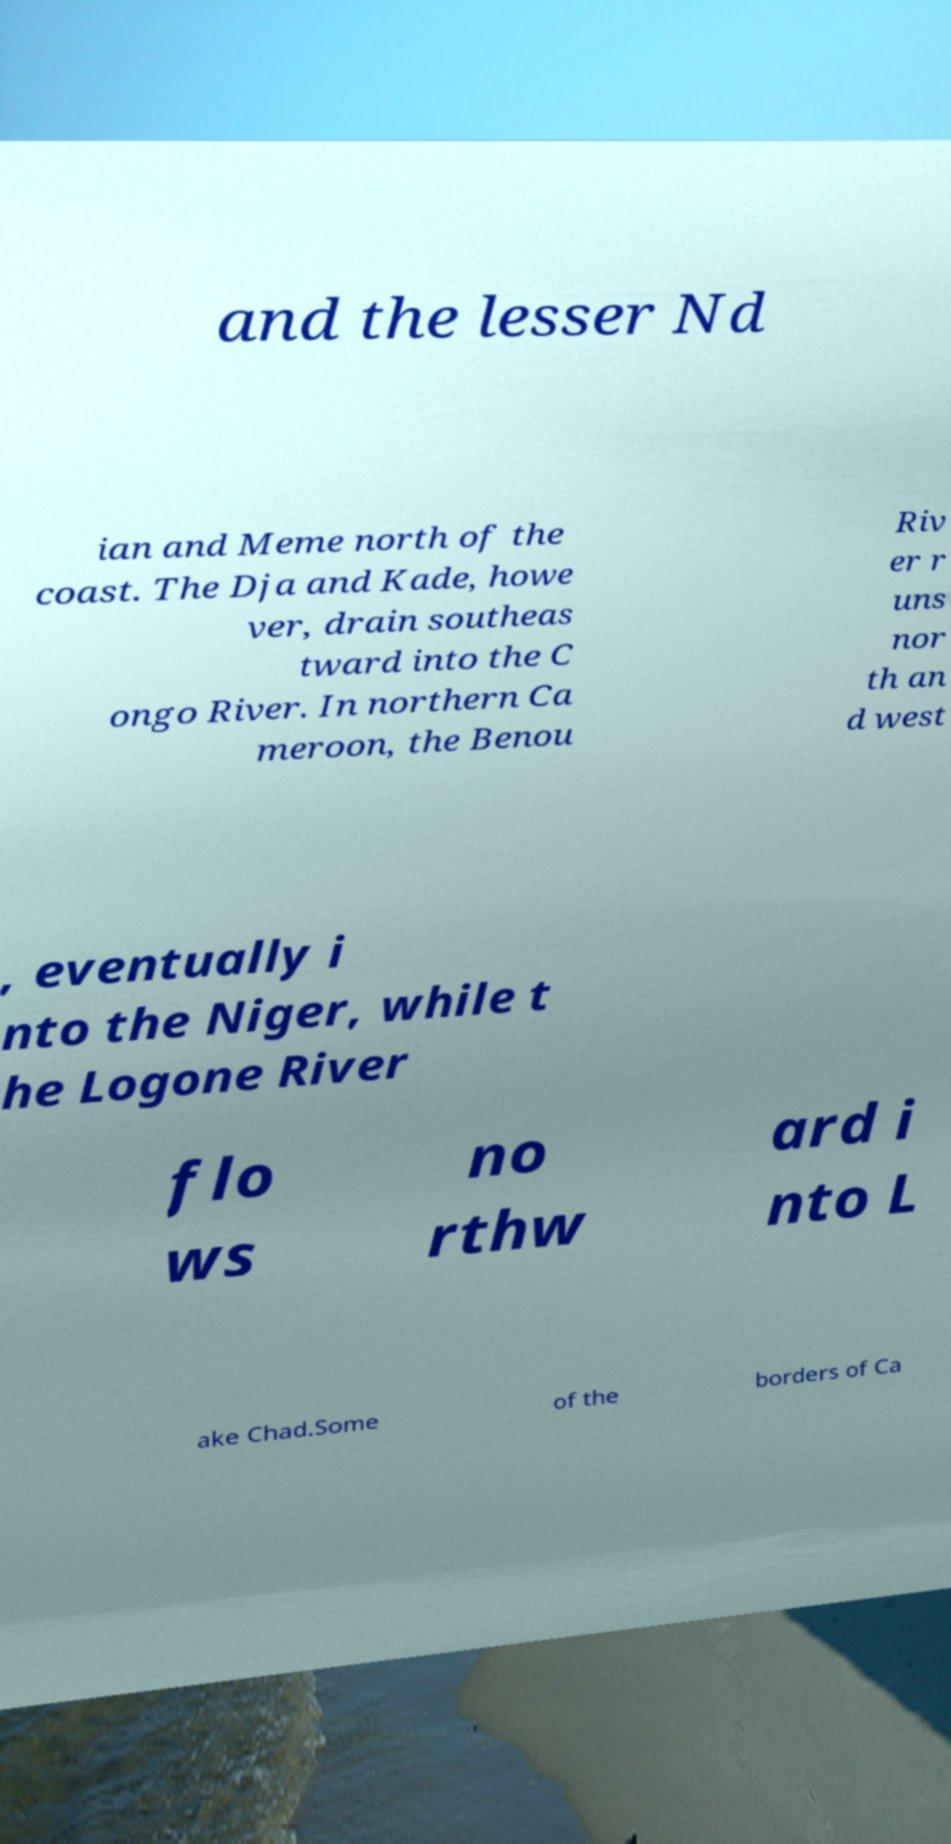Can you read and provide the text displayed in the image?This photo seems to have some interesting text. Can you extract and type it out for me? and the lesser Nd ian and Meme north of the coast. The Dja and Kade, howe ver, drain southeas tward into the C ongo River. In northern Ca meroon, the Benou Riv er r uns nor th an d west , eventually i nto the Niger, while t he Logone River flo ws no rthw ard i nto L ake Chad.Some of the borders of Ca 